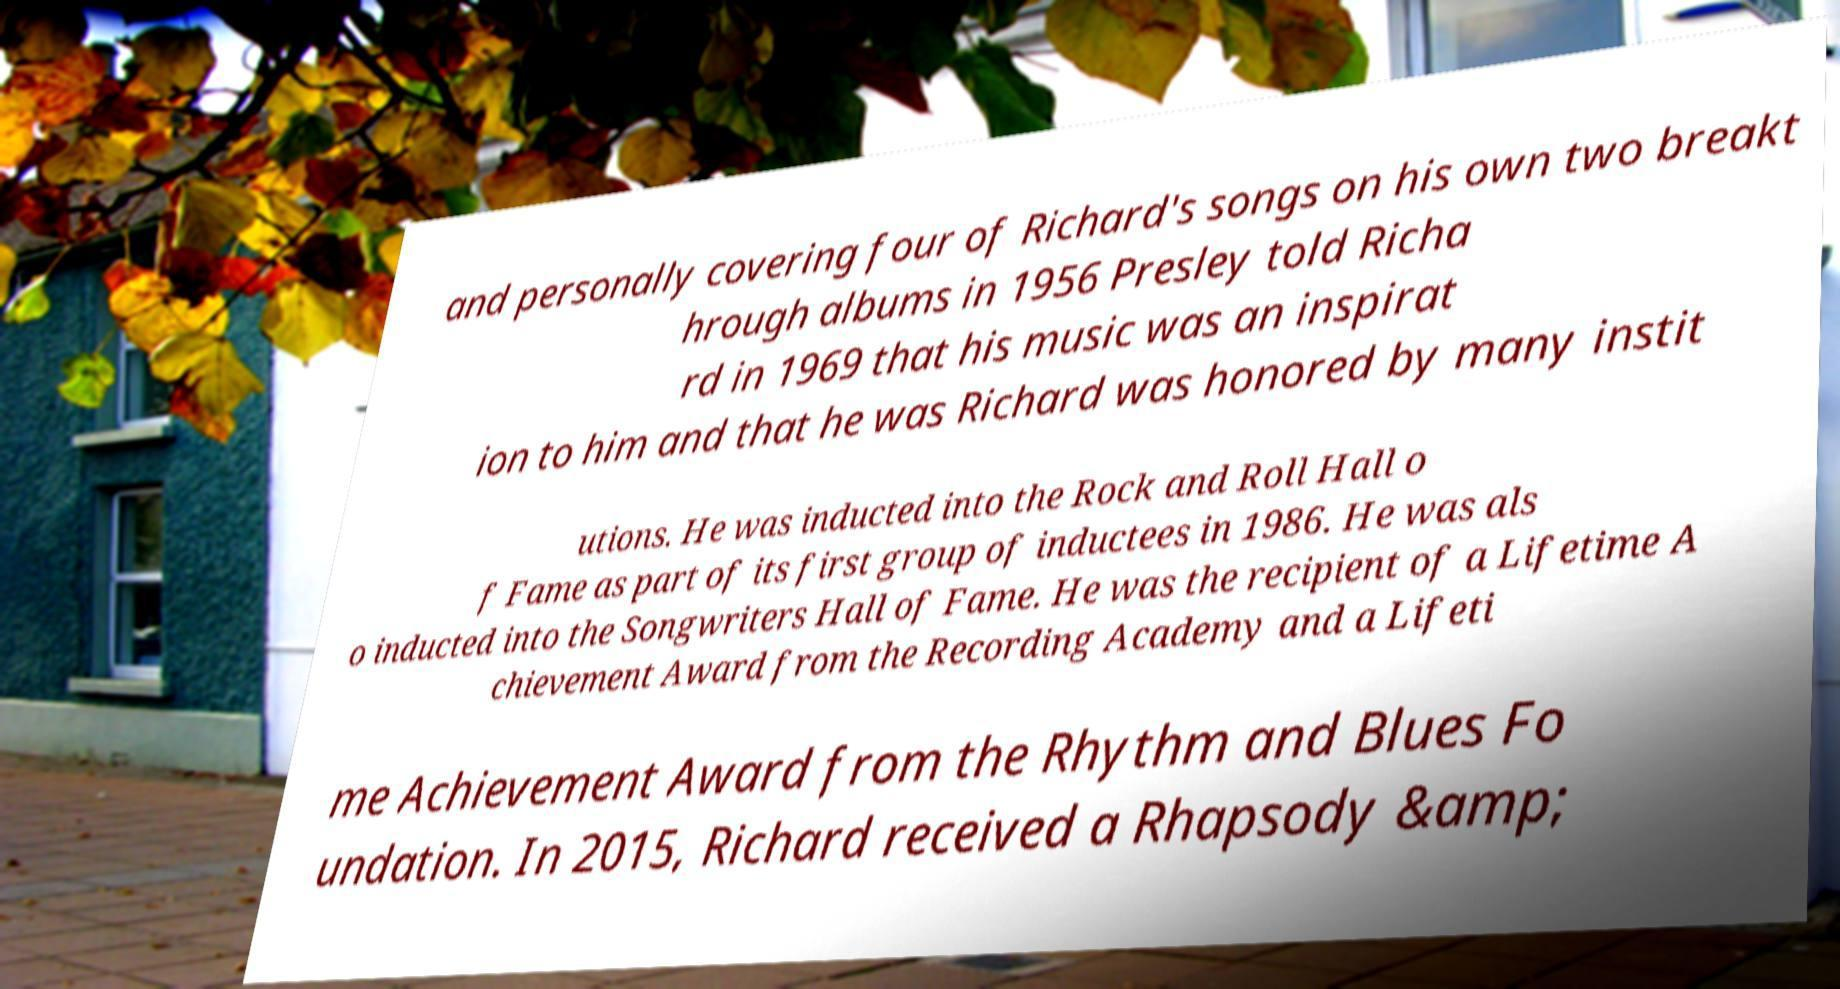For documentation purposes, I need the text within this image transcribed. Could you provide that? and personally covering four of Richard's songs on his own two breakt hrough albums in 1956 Presley told Richa rd in 1969 that his music was an inspirat ion to him and that he was Richard was honored by many instit utions. He was inducted into the Rock and Roll Hall o f Fame as part of its first group of inductees in 1986. He was als o inducted into the Songwriters Hall of Fame. He was the recipient of a Lifetime A chievement Award from the Recording Academy and a Lifeti me Achievement Award from the Rhythm and Blues Fo undation. In 2015, Richard received a Rhapsody &amp; 